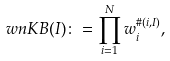Convert formula to latex. <formula><loc_0><loc_0><loc_500><loc_500>\ w n K B ( I ) \colon = \prod _ { i = 1 } ^ { N } w _ { i } ^ { \# ( i , I ) } ,</formula> 